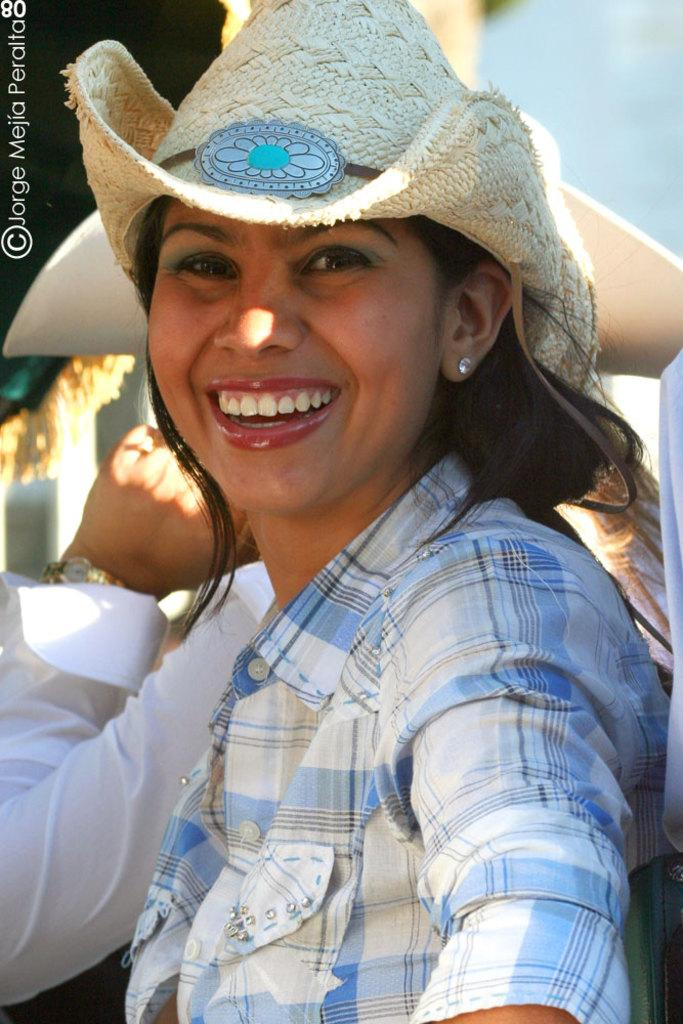Who is present in the image? There is a woman in the image. What is the woman doing in the image? The woman is standing and smiling. What is the woman wearing on her head? The woman is wearing a hat. Can you describe the presence of another person in the image? There is another person standing behind the woman. What type of badge is the woman holding in the image? There is no badge present in the image. Can you describe the potato that the woman is holding in the image? There is no potato present in the image. 